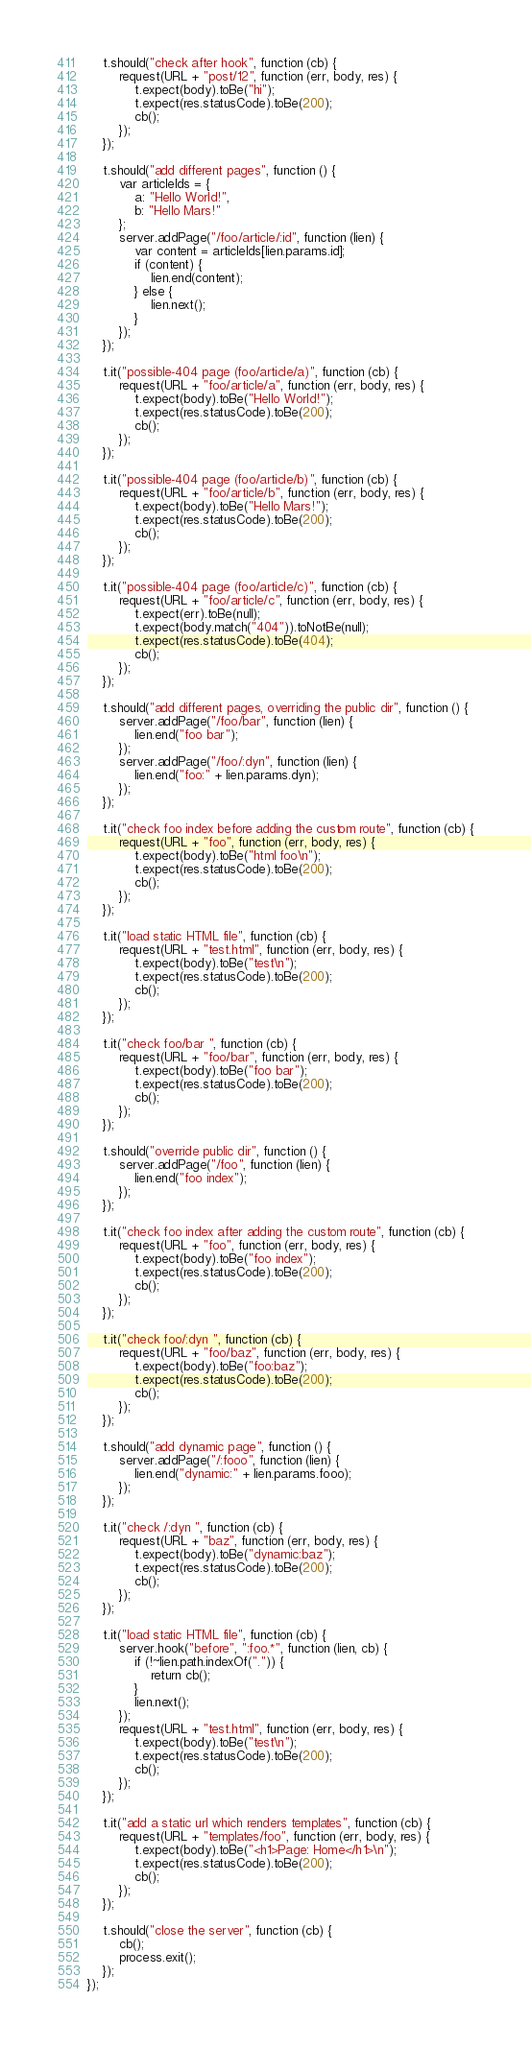Convert code to text. <code><loc_0><loc_0><loc_500><loc_500><_JavaScript_>    t.should("check after hook", function (cb) {
        request(URL + "post/12", function (err, body, res) {
            t.expect(body).toBe("hi");
            t.expect(res.statusCode).toBe(200);
            cb();
        });
    });

    t.should("add different pages", function () {
        var articleIds = {
            a: "Hello World!",
            b: "Hello Mars!"
        };
        server.addPage("/foo/article/:id", function (lien) {
            var content = articleIds[lien.params.id];
            if (content) {
                lien.end(content);
            } else {
                lien.next();
            }
        });
    });

    t.it("possible-404 page (foo/article/a)", function (cb) {
        request(URL + "foo/article/a", function (err, body, res) {
            t.expect(body).toBe("Hello World!");
            t.expect(res.statusCode).toBe(200);
            cb();
        });
    });

    t.it("possible-404 page (foo/article/b)", function (cb) {
        request(URL + "foo/article/b", function (err, body, res) {
            t.expect(body).toBe("Hello Mars!");
            t.expect(res.statusCode).toBe(200);
            cb();
        });
    });

    t.it("possible-404 page (foo/article/c)", function (cb) {
        request(URL + "foo/article/c", function (err, body, res) {
            t.expect(err).toBe(null);
            t.expect(body.match("404")).toNotBe(null);
            t.expect(res.statusCode).toBe(404);
            cb();
        });
    });

    t.should("add different pages, overriding the public dir", function () {
        server.addPage("/foo/bar", function (lien) {
            lien.end("foo bar");
        });
        server.addPage("/foo/:dyn", function (lien) {
            lien.end("foo:" + lien.params.dyn);
        });
    });

    t.it("check foo index before adding the custom route", function (cb) {
        request(URL + "foo", function (err, body, res) {
            t.expect(body).toBe("html foo\n");
            t.expect(res.statusCode).toBe(200);
            cb();
        });
    });

    t.it("load static HTML file", function (cb) {
        request(URL + "test.html", function (err, body, res) {
            t.expect(body).toBe("test\n");
            t.expect(res.statusCode).toBe(200);
            cb();
        });
    });

    t.it("check foo/bar ", function (cb) {
        request(URL + "foo/bar", function (err, body, res) {
            t.expect(body).toBe("foo bar");
            t.expect(res.statusCode).toBe(200);
            cb();
        });
    });

    t.should("override public dir", function () {
        server.addPage("/foo", function (lien) {
            lien.end("foo index");
        });
    });

    t.it("check foo index after adding the custom route", function (cb) {
        request(URL + "foo", function (err, body, res) {
            t.expect(body).toBe("foo index");
            t.expect(res.statusCode).toBe(200);
            cb();
        });
    });

    t.it("check foo/:dyn ", function (cb) {
        request(URL + "foo/baz", function (err, body, res) {
            t.expect(body).toBe("foo:baz");
            t.expect(res.statusCode).toBe(200);
            cb();
        });
    });

    t.should("add dynamic page", function () {
        server.addPage("/:fooo", function (lien) {
            lien.end("dynamic:" + lien.params.fooo);
        });
    });

    t.it("check /:dyn ", function (cb) {
        request(URL + "baz", function (err, body, res) {
            t.expect(body).toBe("dynamic:baz");
            t.expect(res.statusCode).toBe(200);
            cb();
        });
    });

    t.it("load static HTML file", function (cb) {
        server.hook("before", ":foo.*", function (lien, cb) {
            if (!~lien.path.indexOf(".")) {
                return cb();
            }
            lien.next();
        });
        request(URL + "test.html", function (err, body, res) {
            t.expect(body).toBe("test\n");
            t.expect(res.statusCode).toBe(200);
            cb();
        });
    });

    t.it("add a static url which renders templates", function (cb) {
        request(URL + "templates/foo", function (err, body, res) {
            t.expect(body).toBe("<h1>Page: Home</h1>\n");
            t.expect(res.statusCode).toBe(200);
            cb();
        });
    });

    t.should("close the server", function (cb) {
        cb();
        process.exit();
    });
});</code> 